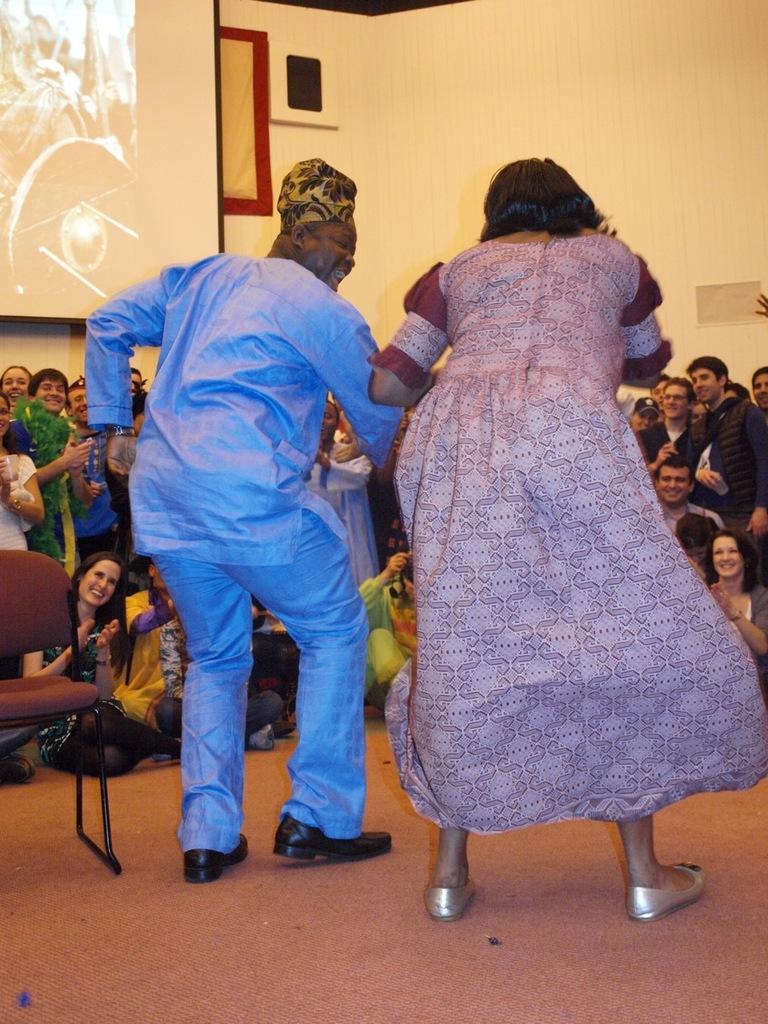In one or two sentences, can you explain what this image depicts? In this image I can see two people with different color dresses. In-front of these people I can see the group of people with colorful dresses. In the background I can see the screen and the wall. To the left I can see the chair. 